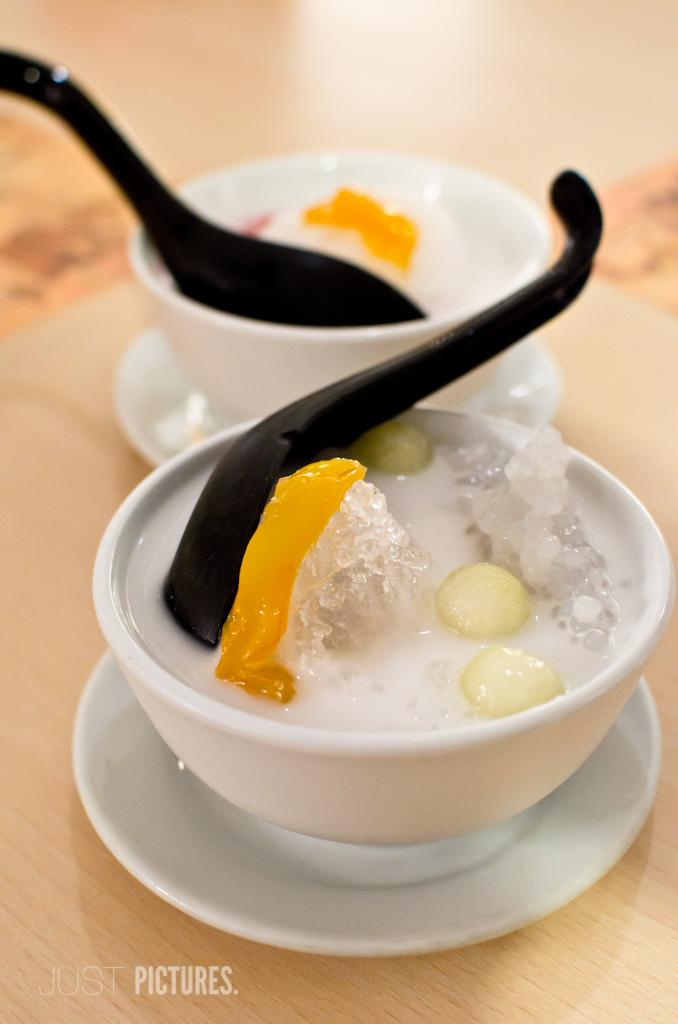How many cups are visible in the image? There are two cups in the image. What is used to stir or scoop the sweet in the cups? There are two spoons in the image. What is inside the cups? There is sweet in the cups. What type of engine can be seen powering the cups in the image? There is no engine present in the image, and the cups are not powered by any engine. 